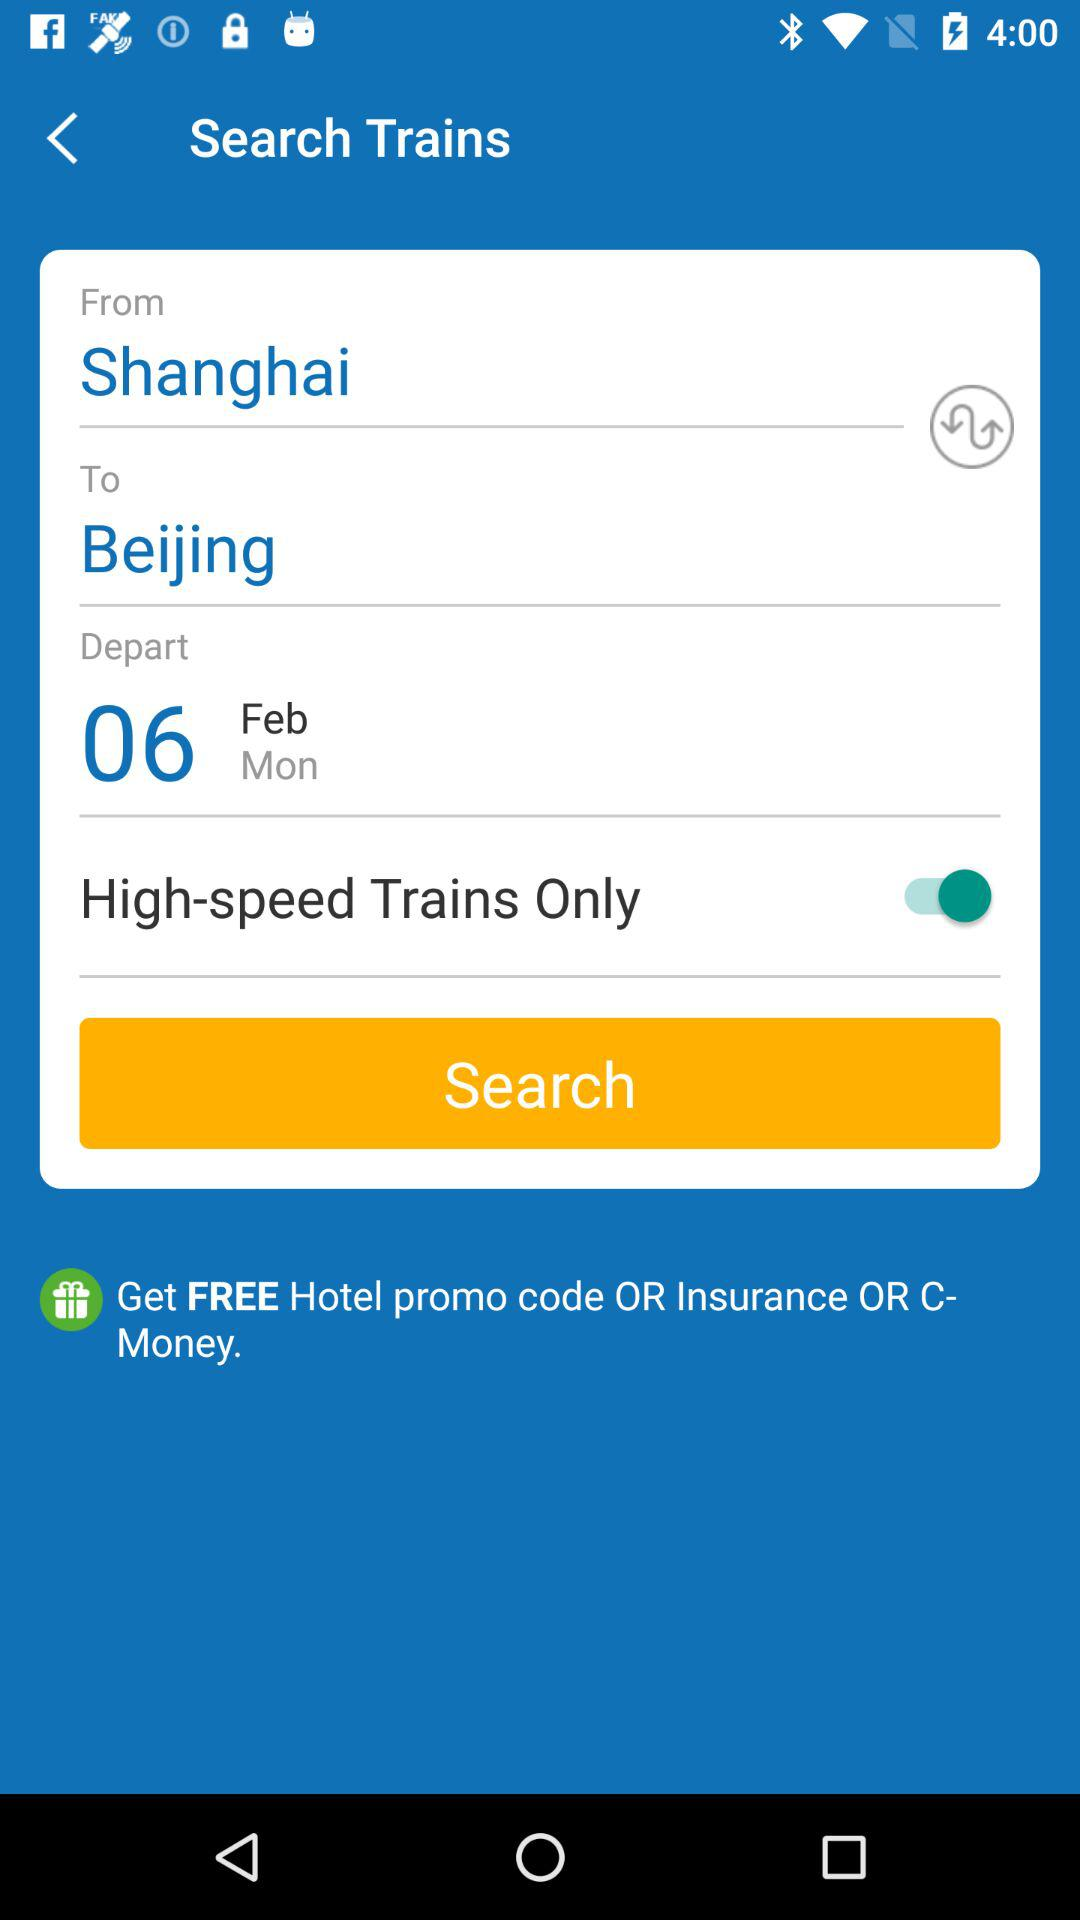What is the destination city? The destination city is Beijing. 